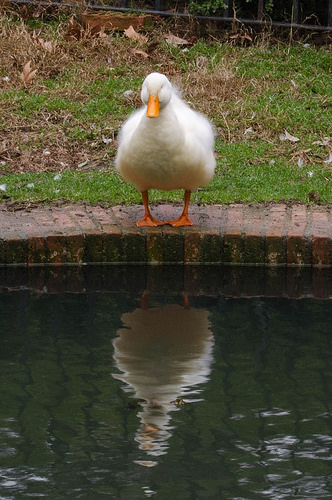<image>
Can you confirm if the duck is to the right of the brick? No. The duck is not to the right of the brick. The horizontal positioning shows a different relationship. 